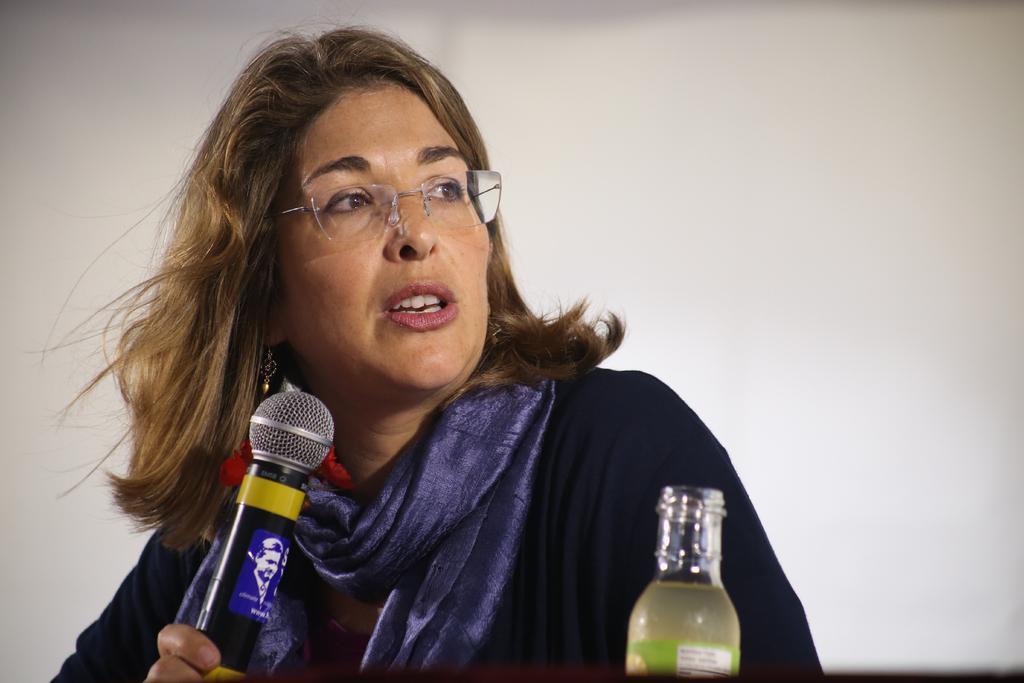In one or two sentences, can you explain what this image depicts? As we can see in the image there is a woman holding mic and there is a bottle over here. 